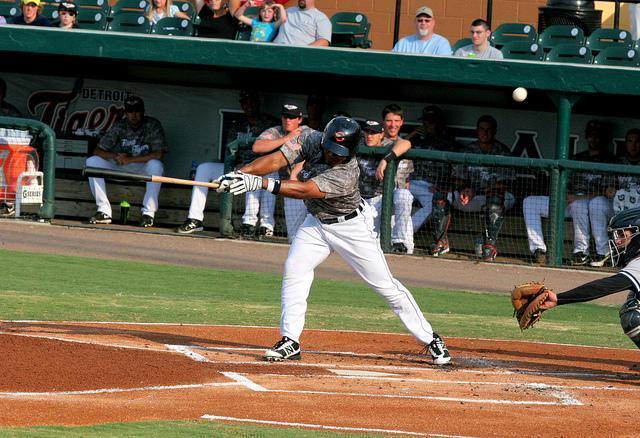How many chairs can be seen?
Give a very brief answer. 1. How many people can be seen?
Give a very brief answer. 9. 